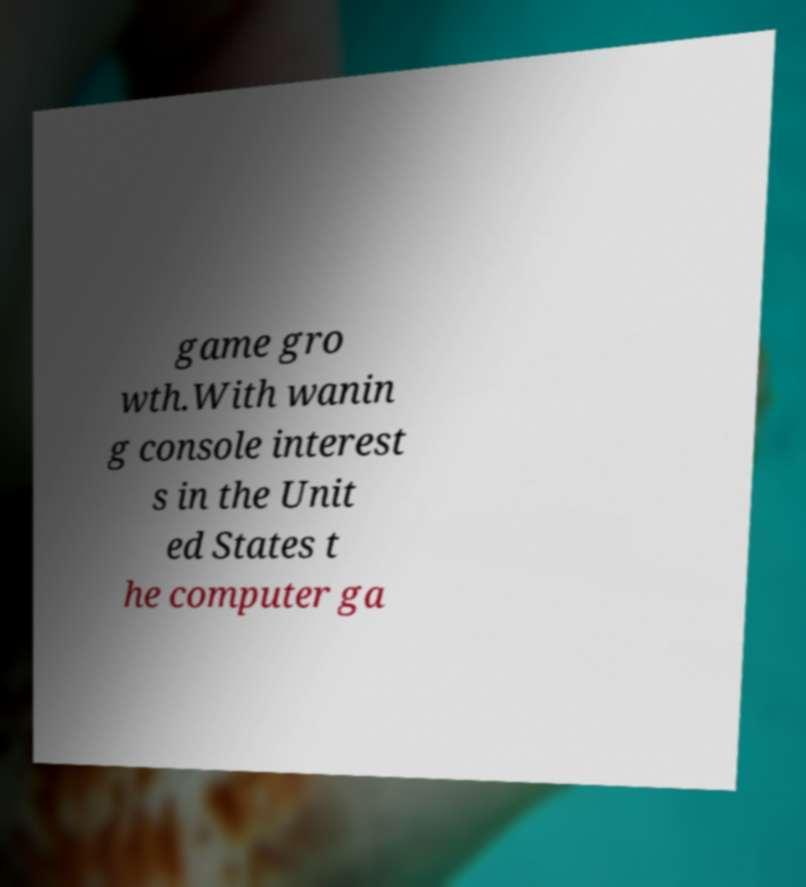What messages or text are displayed in this image? I need them in a readable, typed format. game gro wth.With wanin g console interest s in the Unit ed States t he computer ga 